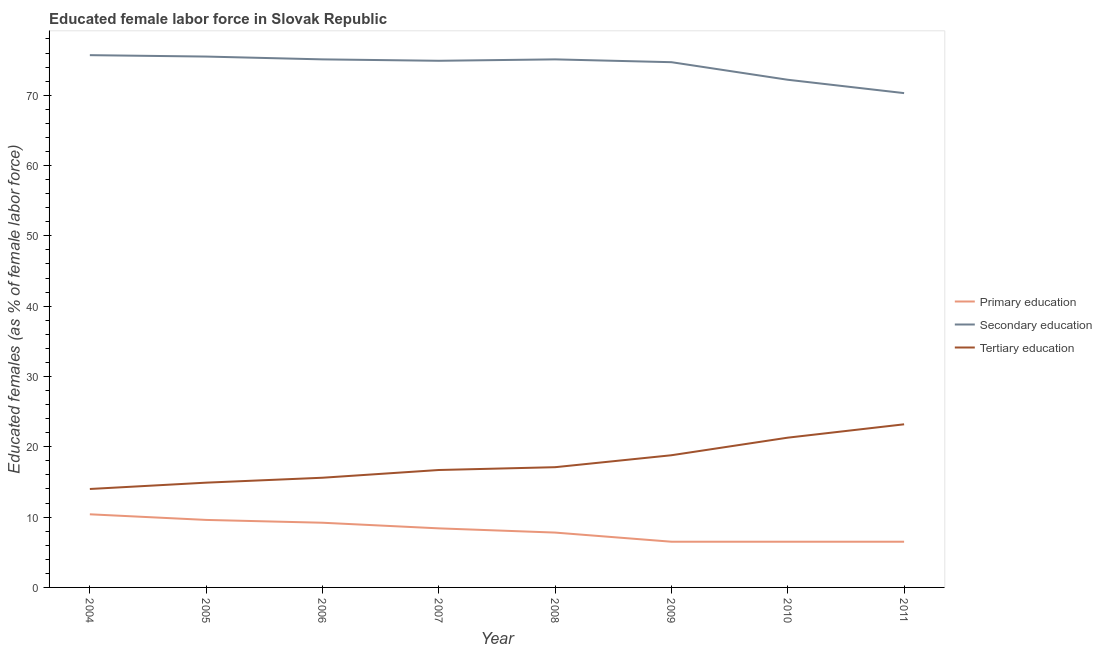Does the line corresponding to percentage of female labor force who received primary education intersect with the line corresponding to percentage of female labor force who received tertiary education?
Your answer should be very brief. No. Is the number of lines equal to the number of legend labels?
Offer a terse response. Yes. Across all years, what is the maximum percentage of female labor force who received tertiary education?
Your answer should be compact. 23.2. Across all years, what is the minimum percentage of female labor force who received secondary education?
Give a very brief answer. 70.3. What is the total percentage of female labor force who received secondary education in the graph?
Provide a short and direct response. 593.5. What is the difference between the percentage of female labor force who received secondary education in 2006 and that in 2011?
Provide a short and direct response. 4.8. What is the difference between the percentage of female labor force who received tertiary education in 2004 and the percentage of female labor force who received primary education in 2009?
Offer a terse response. 7.5. What is the average percentage of female labor force who received primary education per year?
Keep it short and to the point. 8.11. In the year 2006, what is the difference between the percentage of female labor force who received tertiary education and percentage of female labor force who received primary education?
Keep it short and to the point. 6.4. In how many years, is the percentage of female labor force who received primary education greater than 44 %?
Make the answer very short. 0. What is the ratio of the percentage of female labor force who received tertiary education in 2004 to that in 2010?
Provide a short and direct response. 0.66. Is the percentage of female labor force who received tertiary education in 2008 less than that in 2011?
Your response must be concise. Yes. Is the difference between the percentage of female labor force who received secondary education in 2004 and 2007 greater than the difference between the percentage of female labor force who received primary education in 2004 and 2007?
Your answer should be very brief. No. What is the difference between the highest and the second highest percentage of female labor force who received secondary education?
Make the answer very short. 0.2. What is the difference between the highest and the lowest percentage of female labor force who received tertiary education?
Your answer should be compact. 9.2. In how many years, is the percentage of female labor force who received primary education greater than the average percentage of female labor force who received primary education taken over all years?
Provide a succinct answer. 4. Is it the case that in every year, the sum of the percentage of female labor force who received primary education and percentage of female labor force who received secondary education is greater than the percentage of female labor force who received tertiary education?
Offer a terse response. Yes. Does the percentage of female labor force who received secondary education monotonically increase over the years?
Your answer should be very brief. No. Is the percentage of female labor force who received secondary education strictly greater than the percentage of female labor force who received primary education over the years?
Keep it short and to the point. Yes. Are the values on the major ticks of Y-axis written in scientific E-notation?
Your response must be concise. No. Does the graph contain any zero values?
Provide a succinct answer. No. Does the graph contain grids?
Offer a very short reply. No. How many legend labels are there?
Make the answer very short. 3. What is the title of the graph?
Provide a succinct answer. Educated female labor force in Slovak Republic. What is the label or title of the X-axis?
Offer a terse response. Year. What is the label or title of the Y-axis?
Ensure brevity in your answer.  Educated females (as % of female labor force). What is the Educated females (as % of female labor force) in Primary education in 2004?
Give a very brief answer. 10.4. What is the Educated females (as % of female labor force) of Secondary education in 2004?
Offer a terse response. 75.7. What is the Educated females (as % of female labor force) of Primary education in 2005?
Make the answer very short. 9.6. What is the Educated females (as % of female labor force) in Secondary education in 2005?
Give a very brief answer. 75.5. What is the Educated females (as % of female labor force) in Tertiary education in 2005?
Ensure brevity in your answer.  14.9. What is the Educated females (as % of female labor force) of Primary education in 2006?
Keep it short and to the point. 9.2. What is the Educated females (as % of female labor force) of Secondary education in 2006?
Your answer should be very brief. 75.1. What is the Educated females (as % of female labor force) of Tertiary education in 2006?
Keep it short and to the point. 15.6. What is the Educated females (as % of female labor force) of Primary education in 2007?
Your answer should be compact. 8.4. What is the Educated females (as % of female labor force) of Secondary education in 2007?
Give a very brief answer. 74.9. What is the Educated females (as % of female labor force) of Tertiary education in 2007?
Offer a very short reply. 16.7. What is the Educated females (as % of female labor force) of Primary education in 2008?
Provide a short and direct response. 7.8. What is the Educated females (as % of female labor force) in Secondary education in 2008?
Ensure brevity in your answer.  75.1. What is the Educated females (as % of female labor force) of Tertiary education in 2008?
Your answer should be very brief. 17.1. What is the Educated females (as % of female labor force) in Primary education in 2009?
Make the answer very short. 6.5. What is the Educated females (as % of female labor force) of Secondary education in 2009?
Keep it short and to the point. 74.7. What is the Educated females (as % of female labor force) in Tertiary education in 2009?
Your response must be concise. 18.8. What is the Educated females (as % of female labor force) in Secondary education in 2010?
Ensure brevity in your answer.  72.2. What is the Educated females (as % of female labor force) in Tertiary education in 2010?
Keep it short and to the point. 21.3. What is the Educated females (as % of female labor force) in Secondary education in 2011?
Keep it short and to the point. 70.3. What is the Educated females (as % of female labor force) of Tertiary education in 2011?
Your response must be concise. 23.2. Across all years, what is the maximum Educated females (as % of female labor force) of Primary education?
Keep it short and to the point. 10.4. Across all years, what is the maximum Educated females (as % of female labor force) of Secondary education?
Provide a succinct answer. 75.7. Across all years, what is the maximum Educated females (as % of female labor force) of Tertiary education?
Provide a succinct answer. 23.2. Across all years, what is the minimum Educated females (as % of female labor force) in Primary education?
Provide a short and direct response. 6.5. Across all years, what is the minimum Educated females (as % of female labor force) of Secondary education?
Give a very brief answer. 70.3. Across all years, what is the minimum Educated females (as % of female labor force) in Tertiary education?
Ensure brevity in your answer.  14. What is the total Educated females (as % of female labor force) in Primary education in the graph?
Provide a succinct answer. 64.9. What is the total Educated females (as % of female labor force) in Secondary education in the graph?
Provide a succinct answer. 593.5. What is the total Educated females (as % of female labor force) of Tertiary education in the graph?
Keep it short and to the point. 141.6. What is the difference between the Educated females (as % of female labor force) of Tertiary education in 2004 and that in 2005?
Give a very brief answer. -0.9. What is the difference between the Educated females (as % of female labor force) in Tertiary education in 2004 and that in 2006?
Keep it short and to the point. -1.6. What is the difference between the Educated females (as % of female labor force) in Primary education in 2004 and that in 2007?
Provide a succinct answer. 2. What is the difference between the Educated females (as % of female labor force) in Tertiary education in 2004 and that in 2007?
Offer a terse response. -2.7. What is the difference between the Educated females (as % of female labor force) of Primary education in 2004 and that in 2008?
Your response must be concise. 2.6. What is the difference between the Educated females (as % of female labor force) in Secondary education in 2004 and that in 2008?
Make the answer very short. 0.6. What is the difference between the Educated females (as % of female labor force) in Tertiary education in 2004 and that in 2008?
Your response must be concise. -3.1. What is the difference between the Educated females (as % of female labor force) of Primary education in 2004 and that in 2010?
Keep it short and to the point. 3.9. What is the difference between the Educated females (as % of female labor force) of Secondary education in 2004 and that in 2010?
Provide a succinct answer. 3.5. What is the difference between the Educated females (as % of female labor force) in Tertiary education in 2004 and that in 2010?
Your answer should be very brief. -7.3. What is the difference between the Educated females (as % of female labor force) in Primary education in 2005 and that in 2006?
Your answer should be compact. 0.4. What is the difference between the Educated females (as % of female labor force) of Secondary education in 2005 and that in 2006?
Ensure brevity in your answer.  0.4. What is the difference between the Educated females (as % of female labor force) in Tertiary education in 2005 and that in 2006?
Your response must be concise. -0.7. What is the difference between the Educated females (as % of female labor force) of Secondary education in 2005 and that in 2007?
Offer a terse response. 0.6. What is the difference between the Educated females (as % of female labor force) of Tertiary education in 2005 and that in 2007?
Offer a terse response. -1.8. What is the difference between the Educated females (as % of female labor force) of Primary education in 2005 and that in 2008?
Provide a short and direct response. 1.8. What is the difference between the Educated females (as % of female labor force) in Tertiary education in 2005 and that in 2008?
Keep it short and to the point. -2.2. What is the difference between the Educated females (as % of female labor force) of Primary education in 2005 and that in 2010?
Your response must be concise. 3.1. What is the difference between the Educated females (as % of female labor force) in Secondary education in 2005 and that in 2010?
Your response must be concise. 3.3. What is the difference between the Educated females (as % of female labor force) of Primary education in 2005 and that in 2011?
Offer a terse response. 3.1. What is the difference between the Educated females (as % of female labor force) of Secondary education in 2006 and that in 2007?
Your answer should be compact. 0.2. What is the difference between the Educated females (as % of female labor force) of Tertiary education in 2006 and that in 2007?
Ensure brevity in your answer.  -1.1. What is the difference between the Educated females (as % of female labor force) of Secondary education in 2006 and that in 2008?
Ensure brevity in your answer.  0. What is the difference between the Educated females (as % of female labor force) of Primary education in 2006 and that in 2009?
Offer a terse response. 2.7. What is the difference between the Educated females (as % of female labor force) in Primary education in 2006 and that in 2010?
Ensure brevity in your answer.  2.7. What is the difference between the Educated females (as % of female labor force) of Tertiary education in 2006 and that in 2010?
Give a very brief answer. -5.7. What is the difference between the Educated females (as % of female labor force) of Primary education in 2006 and that in 2011?
Make the answer very short. 2.7. What is the difference between the Educated females (as % of female labor force) of Secondary education in 2006 and that in 2011?
Provide a short and direct response. 4.8. What is the difference between the Educated females (as % of female labor force) in Primary education in 2007 and that in 2008?
Give a very brief answer. 0.6. What is the difference between the Educated females (as % of female labor force) in Primary education in 2007 and that in 2009?
Keep it short and to the point. 1.9. What is the difference between the Educated females (as % of female labor force) of Secondary education in 2007 and that in 2009?
Keep it short and to the point. 0.2. What is the difference between the Educated females (as % of female labor force) in Tertiary education in 2007 and that in 2010?
Your response must be concise. -4.6. What is the difference between the Educated females (as % of female labor force) in Primary education in 2007 and that in 2011?
Offer a terse response. 1.9. What is the difference between the Educated females (as % of female labor force) of Secondary education in 2007 and that in 2011?
Offer a terse response. 4.6. What is the difference between the Educated females (as % of female labor force) of Primary education in 2008 and that in 2009?
Make the answer very short. 1.3. What is the difference between the Educated females (as % of female labor force) of Tertiary education in 2008 and that in 2009?
Your answer should be compact. -1.7. What is the difference between the Educated females (as % of female labor force) in Primary education in 2008 and that in 2010?
Your response must be concise. 1.3. What is the difference between the Educated females (as % of female labor force) in Secondary education in 2008 and that in 2010?
Your answer should be very brief. 2.9. What is the difference between the Educated females (as % of female labor force) in Tertiary education in 2008 and that in 2010?
Offer a very short reply. -4.2. What is the difference between the Educated females (as % of female labor force) in Primary education in 2008 and that in 2011?
Make the answer very short. 1.3. What is the difference between the Educated females (as % of female labor force) in Tertiary education in 2008 and that in 2011?
Make the answer very short. -6.1. What is the difference between the Educated females (as % of female labor force) in Secondary education in 2009 and that in 2010?
Make the answer very short. 2.5. What is the difference between the Educated females (as % of female labor force) of Tertiary education in 2009 and that in 2010?
Ensure brevity in your answer.  -2.5. What is the difference between the Educated females (as % of female labor force) of Primary education in 2009 and that in 2011?
Keep it short and to the point. 0. What is the difference between the Educated females (as % of female labor force) of Secondary education in 2009 and that in 2011?
Make the answer very short. 4.4. What is the difference between the Educated females (as % of female labor force) of Tertiary education in 2010 and that in 2011?
Your answer should be very brief. -1.9. What is the difference between the Educated females (as % of female labor force) of Primary education in 2004 and the Educated females (as % of female labor force) of Secondary education in 2005?
Make the answer very short. -65.1. What is the difference between the Educated females (as % of female labor force) of Primary education in 2004 and the Educated females (as % of female labor force) of Tertiary education in 2005?
Give a very brief answer. -4.5. What is the difference between the Educated females (as % of female labor force) in Secondary education in 2004 and the Educated females (as % of female labor force) in Tertiary education in 2005?
Provide a succinct answer. 60.8. What is the difference between the Educated females (as % of female labor force) of Primary education in 2004 and the Educated females (as % of female labor force) of Secondary education in 2006?
Offer a very short reply. -64.7. What is the difference between the Educated females (as % of female labor force) of Secondary education in 2004 and the Educated females (as % of female labor force) of Tertiary education in 2006?
Make the answer very short. 60.1. What is the difference between the Educated females (as % of female labor force) of Primary education in 2004 and the Educated females (as % of female labor force) of Secondary education in 2007?
Offer a terse response. -64.5. What is the difference between the Educated females (as % of female labor force) of Primary education in 2004 and the Educated females (as % of female labor force) of Tertiary education in 2007?
Ensure brevity in your answer.  -6.3. What is the difference between the Educated females (as % of female labor force) in Secondary education in 2004 and the Educated females (as % of female labor force) in Tertiary education in 2007?
Your answer should be very brief. 59. What is the difference between the Educated females (as % of female labor force) in Primary education in 2004 and the Educated females (as % of female labor force) in Secondary education in 2008?
Your answer should be very brief. -64.7. What is the difference between the Educated females (as % of female labor force) of Secondary education in 2004 and the Educated females (as % of female labor force) of Tertiary education in 2008?
Give a very brief answer. 58.6. What is the difference between the Educated females (as % of female labor force) of Primary education in 2004 and the Educated females (as % of female labor force) of Secondary education in 2009?
Make the answer very short. -64.3. What is the difference between the Educated females (as % of female labor force) of Primary education in 2004 and the Educated females (as % of female labor force) of Tertiary education in 2009?
Make the answer very short. -8.4. What is the difference between the Educated females (as % of female labor force) in Secondary education in 2004 and the Educated females (as % of female labor force) in Tertiary education in 2009?
Ensure brevity in your answer.  56.9. What is the difference between the Educated females (as % of female labor force) in Primary education in 2004 and the Educated females (as % of female labor force) in Secondary education in 2010?
Offer a very short reply. -61.8. What is the difference between the Educated females (as % of female labor force) of Secondary education in 2004 and the Educated females (as % of female labor force) of Tertiary education in 2010?
Provide a succinct answer. 54.4. What is the difference between the Educated females (as % of female labor force) in Primary education in 2004 and the Educated females (as % of female labor force) in Secondary education in 2011?
Provide a succinct answer. -59.9. What is the difference between the Educated females (as % of female labor force) in Primary education in 2004 and the Educated females (as % of female labor force) in Tertiary education in 2011?
Your answer should be compact. -12.8. What is the difference between the Educated females (as % of female labor force) in Secondary education in 2004 and the Educated females (as % of female labor force) in Tertiary education in 2011?
Keep it short and to the point. 52.5. What is the difference between the Educated females (as % of female labor force) of Primary education in 2005 and the Educated females (as % of female labor force) of Secondary education in 2006?
Offer a terse response. -65.5. What is the difference between the Educated females (as % of female labor force) in Primary education in 2005 and the Educated females (as % of female labor force) in Tertiary education in 2006?
Your response must be concise. -6. What is the difference between the Educated females (as % of female labor force) in Secondary education in 2005 and the Educated females (as % of female labor force) in Tertiary education in 2006?
Your response must be concise. 59.9. What is the difference between the Educated females (as % of female labor force) in Primary education in 2005 and the Educated females (as % of female labor force) in Secondary education in 2007?
Provide a succinct answer. -65.3. What is the difference between the Educated females (as % of female labor force) in Secondary education in 2005 and the Educated females (as % of female labor force) in Tertiary education in 2007?
Provide a short and direct response. 58.8. What is the difference between the Educated females (as % of female labor force) in Primary education in 2005 and the Educated females (as % of female labor force) in Secondary education in 2008?
Keep it short and to the point. -65.5. What is the difference between the Educated females (as % of female labor force) in Primary education in 2005 and the Educated females (as % of female labor force) in Tertiary education in 2008?
Make the answer very short. -7.5. What is the difference between the Educated females (as % of female labor force) in Secondary education in 2005 and the Educated females (as % of female labor force) in Tertiary education in 2008?
Offer a very short reply. 58.4. What is the difference between the Educated females (as % of female labor force) of Primary education in 2005 and the Educated females (as % of female labor force) of Secondary education in 2009?
Your answer should be very brief. -65.1. What is the difference between the Educated females (as % of female labor force) in Primary education in 2005 and the Educated females (as % of female labor force) in Tertiary education in 2009?
Give a very brief answer. -9.2. What is the difference between the Educated females (as % of female labor force) of Secondary education in 2005 and the Educated females (as % of female labor force) of Tertiary education in 2009?
Provide a short and direct response. 56.7. What is the difference between the Educated females (as % of female labor force) of Primary education in 2005 and the Educated females (as % of female labor force) of Secondary education in 2010?
Make the answer very short. -62.6. What is the difference between the Educated females (as % of female labor force) in Secondary education in 2005 and the Educated females (as % of female labor force) in Tertiary education in 2010?
Offer a terse response. 54.2. What is the difference between the Educated females (as % of female labor force) of Primary education in 2005 and the Educated females (as % of female labor force) of Secondary education in 2011?
Your answer should be very brief. -60.7. What is the difference between the Educated females (as % of female labor force) in Primary education in 2005 and the Educated females (as % of female labor force) in Tertiary education in 2011?
Offer a terse response. -13.6. What is the difference between the Educated females (as % of female labor force) of Secondary education in 2005 and the Educated females (as % of female labor force) of Tertiary education in 2011?
Offer a very short reply. 52.3. What is the difference between the Educated females (as % of female labor force) of Primary education in 2006 and the Educated females (as % of female labor force) of Secondary education in 2007?
Offer a terse response. -65.7. What is the difference between the Educated females (as % of female labor force) of Primary education in 2006 and the Educated females (as % of female labor force) of Tertiary education in 2007?
Your answer should be very brief. -7.5. What is the difference between the Educated females (as % of female labor force) of Secondary education in 2006 and the Educated females (as % of female labor force) of Tertiary education in 2007?
Make the answer very short. 58.4. What is the difference between the Educated females (as % of female labor force) of Primary education in 2006 and the Educated females (as % of female labor force) of Secondary education in 2008?
Your response must be concise. -65.9. What is the difference between the Educated females (as % of female labor force) of Primary education in 2006 and the Educated females (as % of female labor force) of Tertiary education in 2008?
Make the answer very short. -7.9. What is the difference between the Educated females (as % of female labor force) in Primary education in 2006 and the Educated females (as % of female labor force) in Secondary education in 2009?
Provide a short and direct response. -65.5. What is the difference between the Educated females (as % of female labor force) of Primary education in 2006 and the Educated females (as % of female labor force) of Tertiary education in 2009?
Provide a short and direct response. -9.6. What is the difference between the Educated females (as % of female labor force) of Secondary education in 2006 and the Educated females (as % of female labor force) of Tertiary education in 2009?
Keep it short and to the point. 56.3. What is the difference between the Educated females (as % of female labor force) of Primary education in 2006 and the Educated females (as % of female labor force) of Secondary education in 2010?
Offer a very short reply. -63. What is the difference between the Educated females (as % of female labor force) in Primary education in 2006 and the Educated females (as % of female labor force) in Tertiary education in 2010?
Make the answer very short. -12.1. What is the difference between the Educated females (as % of female labor force) of Secondary education in 2006 and the Educated females (as % of female labor force) of Tertiary education in 2010?
Ensure brevity in your answer.  53.8. What is the difference between the Educated females (as % of female labor force) of Primary education in 2006 and the Educated females (as % of female labor force) of Secondary education in 2011?
Your response must be concise. -61.1. What is the difference between the Educated females (as % of female labor force) of Secondary education in 2006 and the Educated females (as % of female labor force) of Tertiary education in 2011?
Your answer should be very brief. 51.9. What is the difference between the Educated females (as % of female labor force) in Primary education in 2007 and the Educated females (as % of female labor force) in Secondary education in 2008?
Keep it short and to the point. -66.7. What is the difference between the Educated females (as % of female labor force) in Secondary education in 2007 and the Educated females (as % of female labor force) in Tertiary education in 2008?
Make the answer very short. 57.8. What is the difference between the Educated females (as % of female labor force) in Primary education in 2007 and the Educated females (as % of female labor force) in Secondary education in 2009?
Provide a succinct answer. -66.3. What is the difference between the Educated females (as % of female labor force) of Secondary education in 2007 and the Educated females (as % of female labor force) of Tertiary education in 2009?
Keep it short and to the point. 56.1. What is the difference between the Educated females (as % of female labor force) in Primary education in 2007 and the Educated females (as % of female labor force) in Secondary education in 2010?
Your answer should be compact. -63.8. What is the difference between the Educated females (as % of female labor force) of Primary education in 2007 and the Educated females (as % of female labor force) of Tertiary education in 2010?
Offer a very short reply. -12.9. What is the difference between the Educated females (as % of female labor force) in Secondary education in 2007 and the Educated females (as % of female labor force) in Tertiary education in 2010?
Offer a terse response. 53.6. What is the difference between the Educated females (as % of female labor force) in Primary education in 2007 and the Educated females (as % of female labor force) in Secondary education in 2011?
Offer a terse response. -61.9. What is the difference between the Educated females (as % of female labor force) of Primary education in 2007 and the Educated females (as % of female labor force) of Tertiary education in 2011?
Make the answer very short. -14.8. What is the difference between the Educated females (as % of female labor force) in Secondary education in 2007 and the Educated females (as % of female labor force) in Tertiary education in 2011?
Provide a succinct answer. 51.7. What is the difference between the Educated females (as % of female labor force) of Primary education in 2008 and the Educated females (as % of female labor force) of Secondary education in 2009?
Keep it short and to the point. -66.9. What is the difference between the Educated females (as % of female labor force) of Primary education in 2008 and the Educated females (as % of female labor force) of Tertiary education in 2009?
Provide a short and direct response. -11. What is the difference between the Educated females (as % of female labor force) in Secondary education in 2008 and the Educated females (as % of female labor force) in Tertiary education in 2009?
Ensure brevity in your answer.  56.3. What is the difference between the Educated females (as % of female labor force) of Primary education in 2008 and the Educated females (as % of female labor force) of Secondary education in 2010?
Provide a succinct answer. -64.4. What is the difference between the Educated females (as % of female labor force) in Primary education in 2008 and the Educated females (as % of female labor force) in Tertiary education in 2010?
Offer a very short reply. -13.5. What is the difference between the Educated females (as % of female labor force) in Secondary education in 2008 and the Educated females (as % of female labor force) in Tertiary education in 2010?
Keep it short and to the point. 53.8. What is the difference between the Educated females (as % of female labor force) in Primary education in 2008 and the Educated females (as % of female labor force) in Secondary education in 2011?
Provide a short and direct response. -62.5. What is the difference between the Educated females (as % of female labor force) in Primary education in 2008 and the Educated females (as % of female labor force) in Tertiary education in 2011?
Provide a succinct answer. -15.4. What is the difference between the Educated females (as % of female labor force) in Secondary education in 2008 and the Educated females (as % of female labor force) in Tertiary education in 2011?
Offer a terse response. 51.9. What is the difference between the Educated females (as % of female labor force) of Primary education in 2009 and the Educated females (as % of female labor force) of Secondary education in 2010?
Offer a terse response. -65.7. What is the difference between the Educated females (as % of female labor force) of Primary education in 2009 and the Educated females (as % of female labor force) of Tertiary education in 2010?
Your answer should be compact. -14.8. What is the difference between the Educated females (as % of female labor force) of Secondary education in 2009 and the Educated females (as % of female labor force) of Tertiary education in 2010?
Your response must be concise. 53.4. What is the difference between the Educated females (as % of female labor force) in Primary education in 2009 and the Educated females (as % of female labor force) in Secondary education in 2011?
Provide a short and direct response. -63.8. What is the difference between the Educated females (as % of female labor force) in Primary education in 2009 and the Educated females (as % of female labor force) in Tertiary education in 2011?
Your response must be concise. -16.7. What is the difference between the Educated females (as % of female labor force) of Secondary education in 2009 and the Educated females (as % of female labor force) of Tertiary education in 2011?
Your answer should be very brief. 51.5. What is the difference between the Educated females (as % of female labor force) in Primary education in 2010 and the Educated females (as % of female labor force) in Secondary education in 2011?
Make the answer very short. -63.8. What is the difference between the Educated females (as % of female labor force) in Primary education in 2010 and the Educated females (as % of female labor force) in Tertiary education in 2011?
Your response must be concise. -16.7. What is the average Educated females (as % of female labor force) of Primary education per year?
Keep it short and to the point. 8.11. What is the average Educated females (as % of female labor force) of Secondary education per year?
Offer a very short reply. 74.19. In the year 2004, what is the difference between the Educated females (as % of female labor force) in Primary education and Educated females (as % of female labor force) in Secondary education?
Your answer should be compact. -65.3. In the year 2004, what is the difference between the Educated females (as % of female labor force) in Primary education and Educated females (as % of female labor force) in Tertiary education?
Give a very brief answer. -3.6. In the year 2004, what is the difference between the Educated females (as % of female labor force) of Secondary education and Educated females (as % of female labor force) of Tertiary education?
Ensure brevity in your answer.  61.7. In the year 2005, what is the difference between the Educated females (as % of female labor force) in Primary education and Educated females (as % of female labor force) in Secondary education?
Provide a succinct answer. -65.9. In the year 2005, what is the difference between the Educated females (as % of female labor force) of Primary education and Educated females (as % of female labor force) of Tertiary education?
Give a very brief answer. -5.3. In the year 2005, what is the difference between the Educated females (as % of female labor force) in Secondary education and Educated females (as % of female labor force) in Tertiary education?
Provide a short and direct response. 60.6. In the year 2006, what is the difference between the Educated females (as % of female labor force) of Primary education and Educated females (as % of female labor force) of Secondary education?
Offer a terse response. -65.9. In the year 2006, what is the difference between the Educated females (as % of female labor force) in Secondary education and Educated females (as % of female labor force) in Tertiary education?
Give a very brief answer. 59.5. In the year 2007, what is the difference between the Educated females (as % of female labor force) of Primary education and Educated females (as % of female labor force) of Secondary education?
Offer a terse response. -66.5. In the year 2007, what is the difference between the Educated females (as % of female labor force) in Secondary education and Educated females (as % of female labor force) in Tertiary education?
Give a very brief answer. 58.2. In the year 2008, what is the difference between the Educated females (as % of female labor force) of Primary education and Educated females (as % of female labor force) of Secondary education?
Offer a terse response. -67.3. In the year 2008, what is the difference between the Educated females (as % of female labor force) in Secondary education and Educated females (as % of female labor force) in Tertiary education?
Your answer should be very brief. 58. In the year 2009, what is the difference between the Educated females (as % of female labor force) of Primary education and Educated females (as % of female labor force) of Secondary education?
Provide a short and direct response. -68.2. In the year 2009, what is the difference between the Educated females (as % of female labor force) in Secondary education and Educated females (as % of female labor force) in Tertiary education?
Keep it short and to the point. 55.9. In the year 2010, what is the difference between the Educated females (as % of female labor force) of Primary education and Educated females (as % of female labor force) of Secondary education?
Your answer should be compact. -65.7. In the year 2010, what is the difference between the Educated females (as % of female labor force) of Primary education and Educated females (as % of female labor force) of Tertiary education?
Provide a succinct answer. -14.8. In the year 2010, what is the difference between the Educated females (as % of female labor force) in Secondary education and Educated females (as % of female labor force) in Tertiary education?
Your answer should be very brief. 50.9. In the year 2011, what is the difference between the Educated females (as % of female labor force) in Primary education and Educated females (as % of female labor force) in Secondary education?
Give a very brief answer. -63.8. In the year 2011, what is the difference between the Educated females (as % of female labor force) of Primary education and Educated females (as % of female labor force) of Tertiary education?
Keep it short and to the point. -16.7. In the year 2011, what is the difference between the Educated females (as % of female labor force) of Secondary education and Educated females (as % of female labor force) of Tertiary education?
Keep it short and to the point. 47.1. What is the ratio of the Educated females (as % of female labor force) in Primary education in 2004 to that in 2005?
Provide a succinct answer. 1.08. What is the ratio of the Educated females (as % of female labor force) of Secondary education in 2004 to that in 2005?
Keep it short and to the point. 1. What is the ratio of the Educated females (as % of female labor force) of Tertiary education in 2004 to that in 2005?
Offer a terse response. 0.94. What is the ratio of the Educated females (as % of female labor force) of Primary education in 2004 to that in 2006?
Ensure brevity in your answer.  1.13. What is the ratio of the Educated females (as % of female labor force) in Tertiary education in 2004 to that in 2006?
Your answer should be very brief. 0.9. What is the ratio of the Educated females (as % of female labor force) in Primary education in 2004 to that in 2007?
Provide a short and direct response. 1.24. What is the ratio of the Educated females (as % of female labor force) of Secondary education in 2004 to that in 2007?
Offer a very short reply. 1.01. What is the ratio of the Educated females (as % of female labor force) of Tertiary education in 2004 to that in 2007?
Offer a very short reply. 0.84. What is the ratio of the Educated females (as % of female labor force) of Secondary education in 2004 to that in 2008?
Your answer should be very brief. 1.01. What is the ratio of the Educated females (as % of female labor force) in Tertiary education in 2004 to that in 2008?
Ensure brevity in your answer.  0.82. What is the ratio of the Educated females (as % of female labor force) of Secondary education in 2004 to that in 2009?
Make the answer very short. 1.01. What is the ratio of the Educated females (as % of female labor force) of Tertiary education in 2004 to that in 2009?
Provide a short and direct response. 0.74. What is the ratio of the Educated females (as % of female labor force) in Primary education in 2004 to that in 2010?
Your response must be concise. 1.6. What is the ratio of the Educated females (as % of female labor force) of Secondary education in 2004 to that in 2010?
Provide a short and direct response. 1.05. What is the ratio of the Educated females (as % of female labor force) of Tertiary education in 2004 to that in 2010?
Ensure brevity in your answer.  0.66. What is the ratio of the Educated females (as % of female labor force) of Primary education in 2004 to that in 2011?
Your answer should be compact. 1.6. What is the ratio of the Educated females (as % of female labor force) in Secondary education in 2004 to that in 2011?
Your response must be concise. 1.08. What is the ratio of the Educated females (as % of female labor force) in Tertiary education in 2004 to that in 2011?
Offer a very short reply. 0.6. What is the ratio of the Educated females (as % of female labor force) of Primary education in 2005 to that in 2006?
Make the answer very short. 1.04. What is the ratio of the Educated females (as % of female labor force) of Secondary education in 2005 to that in 2006?
Your answer should be very brief. 1.01. What is the ratio of the Educated females (as % of female labor force) of Tertiary education in 2005 to that in 2006?
Keep it short and to the point. 0.96. What is the ratio of the Educated females (as % of female labor force) of Primary education in 2005 to that in 2007?
Make the answer very short. 1.14. What is the ratio of the Educated females (as % of female labor force) of Secondary education in 2005 to that in 2007?
Give a very brief answer. 1.01. What is the ratio of the Educated females (as % of female labor force) of Tertiary education in 2005 to that in 2007?
Offer a terse response. 0.89. What is the ratio of the Educated females (as % of female labor force) of Primary education in 2005 to that in 2008?
Your answer should be very brief. 1.23. What is the ratio of the Educated females (as % of female labor force) in Tertiary education in 2005 to that in 2008?
Provide a short and direct response. 0.87. What is the ratio of the Educated females (as % of female labor force) in Primary education in 2005 to that in 2009?
Offer a terse response. 1.48. What is the ratio of the Educated females (as % of female labor force) in Secondary education in 2005 to that in 2009?
Your answer should be very brief. 1.01. What is the ratio of the Educated females (as % of female labor force) in Tertiary education in 2005 to that in 2009?
Your answer should be compact. 0.79. What is the ratio of the Educated females (as % of female labor force) of Primary education in 2005 to that in 2010?
Your answer should be very brief. 1.48. What is the ratio of the Educated females (as % of female labor force) in Secondary education in 2005 to that in 2010?
Offer a very short reply. 1.05. What is the ratio of the Educated females (as % of female labor force) of Tertiary education in 2005 to that in 2010?
Your answer should be very brief. 0.7. What is the ratio of the Educated females (as % of female labor force) in Primary education in 2005 to that in 2011?
Your answer should be compact. 1.48. What is the ratio of the Educated females (as % of female labor force) in Secondary education in 2005 to that in 2011?
Ensure brevity in your answer.  1.07. What is the ratio of the Educated females (as % of female labor force) in Tertiary education in 2005 to that in 2011?
Ensure brevity in your answer.  0.64. What is the ratio of the Educated females (as % of female labor force) of Primary education in 2006 to that in 2007?
Keep it short and to the point. 1.1. What is the ratio of the Educated females (as % of female labor force) in Tertiary education in 2006 to that in 2007?
Keep it short and to the point. 0.93. What is the ratio of the Educated females (as % of female labor force) of Primary education in 2006 to that in 2008?
Provide a short and direct response. 1.18. What is the ratio of the Educated females (as % of female labor force) of Secondary education in 2006 to that in 2008?
Your response must be concise. 1. What is the ratio of the Educated females (as % of female labor force) in Tertiary education in 2006 to that in 2008?
Make the answer very short. 0.91. What is the ratio of the Educated females (as % of female labor force) in Primary education in 2006 to that in 2009?
Give a very brief answer. 1.42. What is the ratio of the Educated females (as % of female labor force) in Secondary education in 2006 to that in 2009?
Your response must be concise. 1.01. What is the ratio of the Educated females (as % of female labor force) of Tertiary education in 2006 to that in 2009?
Provide a succinct answer. 0.83. What is the ratio of the Educated females (as % of female labor force) in Primary education in 2006 to that in 2010?
Your answer should be compact. 1.42. What is the ratio of the Educated females (as % of female labor force) in Secondary education in 2006 to that in 2010?
Offer a very short reply. 1.04. What is the ratio of the Educated females (as % of female labor force) of Tertiary education in 2006 to that in 2010?
Ensure brevity in your answer.  0.73. What is the ratio of the Educated females (as % of female labor force) of Primary education in 2006 to that in 2011?
Keep it short and to the point. 1.42. What is the ratio of the Educated females (as % of female labor force) in Secondary education in 2006 to that in 2011?
Offer a terse response. 1.07. What is the ratio of the Educated females (as % of female labor force) of Tertiary education in 2006 to that in 2011?
Your answer should be very brief. 0.67. What is the ratio of the Educated females (as % of female labor force) in Secondary education in 2007 to that in 2008?
Your response must be concise. 1. What is the ratio of the Educated females (as % of female labor force) in Tertiary education in 2007 to that in 2008?
Ensure brevity in your answer.  0.98. What is the ratio of the Educated females (as % of female labor force) in Primary education in 2007 to that in 2009?
Your answer should be very brief. 1.29. What is the ratio of the Educated females (as % of female labor force) in Secondary education in 2007 to that in 2009?
Provide a succinct answer. 1. What is the ratio of the Educated females (as % of female labor force) of Tertiary education in 2007 to that in 2009?
Keep it short and to the point. 0.89. What is the ratio of the Educated females (as % of female labor force) of Primary education in 2007 to that in 2010?
Make the answer very short. 1.29. What is the ratio of the Educated females (as % of female labor force) of Secondary education in 2007 to that in 2010?
Your answer should be compact. 1.04. What is the ratio of the Educated females (as % of female labor force) in Tertiary education in 2007 to that in 2010?
Ensure brevity in your answer.  0.78. What is the ratio of the Educated females (as % of female labor force) in Primary education in 2007 to that in 2011?
Your answer should be compact. 1.29. What is the ratio of the Educated females (as % of female labor force) in Secondary education in 2007 to that in 2011?
Your response must be concise. 1.07. What is the ratio of the Educated females (as % of female labor force) of Tertiary education in 2007 to that in 2011?
Offer a very short reply. 0.72. What is the ratio of the Educated females (as % of female labor force) of Primary education in 2008 to that in 2009?
Make the answer very short. 1.2. What is the ratio of the Educated females (as % of female labor force) of Secondary education in 2008 to that in 2009?
Keep it short and to the point. 1.01. What is the ratio of the Educated females (as % of female labor force) of Tertiary education in 2008 to that in 2009?
Make the answer very short. 0.91. What is the ratio of the Educated females (as % of female labor force) in Primary education in 2008 to that in 2010?
Your answer should be compact. 1.2. What is the ratio of the Educated females (as % of female labor force) of Secondary education in 2008 to that in 2010?
Your response must be concise. 1.04. What is the ratio of the Educated females (as % of female labor force) in Tertiary education in 2008 to that in 2010?
Offer a terse response. 0.8. What is the ratio of the Educated females (as % of female labor force) of Secondary education in 2008 to that in 2011?
Your response must be concise. 1.07. What is the ratio of the Educated females (as % of female labor force) of Tertiary education in 2008 to that in 2011?
Offer a terse response. 0.74. What is the ratio of the Educated females (as % of female labor force) of Primary education in 2009 to that in 2010?
Provide a short and direct response. 1. What is the ratio of the Educated females (as % of female labor force) of Secondary education in 2009 to that in 2010?
Ensure brevity in your answer.  1.03. What is the ratio of the Educated females (as % of female labor force) in Tertiary education in 2009 to that in 2010?
Ensure brevity in your answer.  0.88. What is the ratio of the Educated females (as % of female labor force) of Secondary education in 2009 to that in 2011?
Your answer should be compact. 1.06. What is the ratio of the Educated females (as % of female labor force) in Tertiary education in 2009 to that in 2011?
Your answer should be very brief. 0.81. What is the ratio of the Educated females (as % of female labor force) of Secondary education in 2010 to that in 2011?
Offer a terse response. 1.03. What is the ratio of the Educated females (as % of female labor force) of Tertiary education in 2010 to that in 2011?
Ensure brevity in your answer.  0.92. What is the difference between the highest and the second highest Educated females (as % of female labor force) in Tertiary education?
Keep it short and to the point. 1.9. What is the difference between the highest and the lowest Educated females (as % of female labor force) of Primary education?
Keep it short and to the point. 3.9. What is the difference between the highest and the lowest Educated females (as % of female labor force) of Tertiary education?
Your answer should be compact. 9.2. 